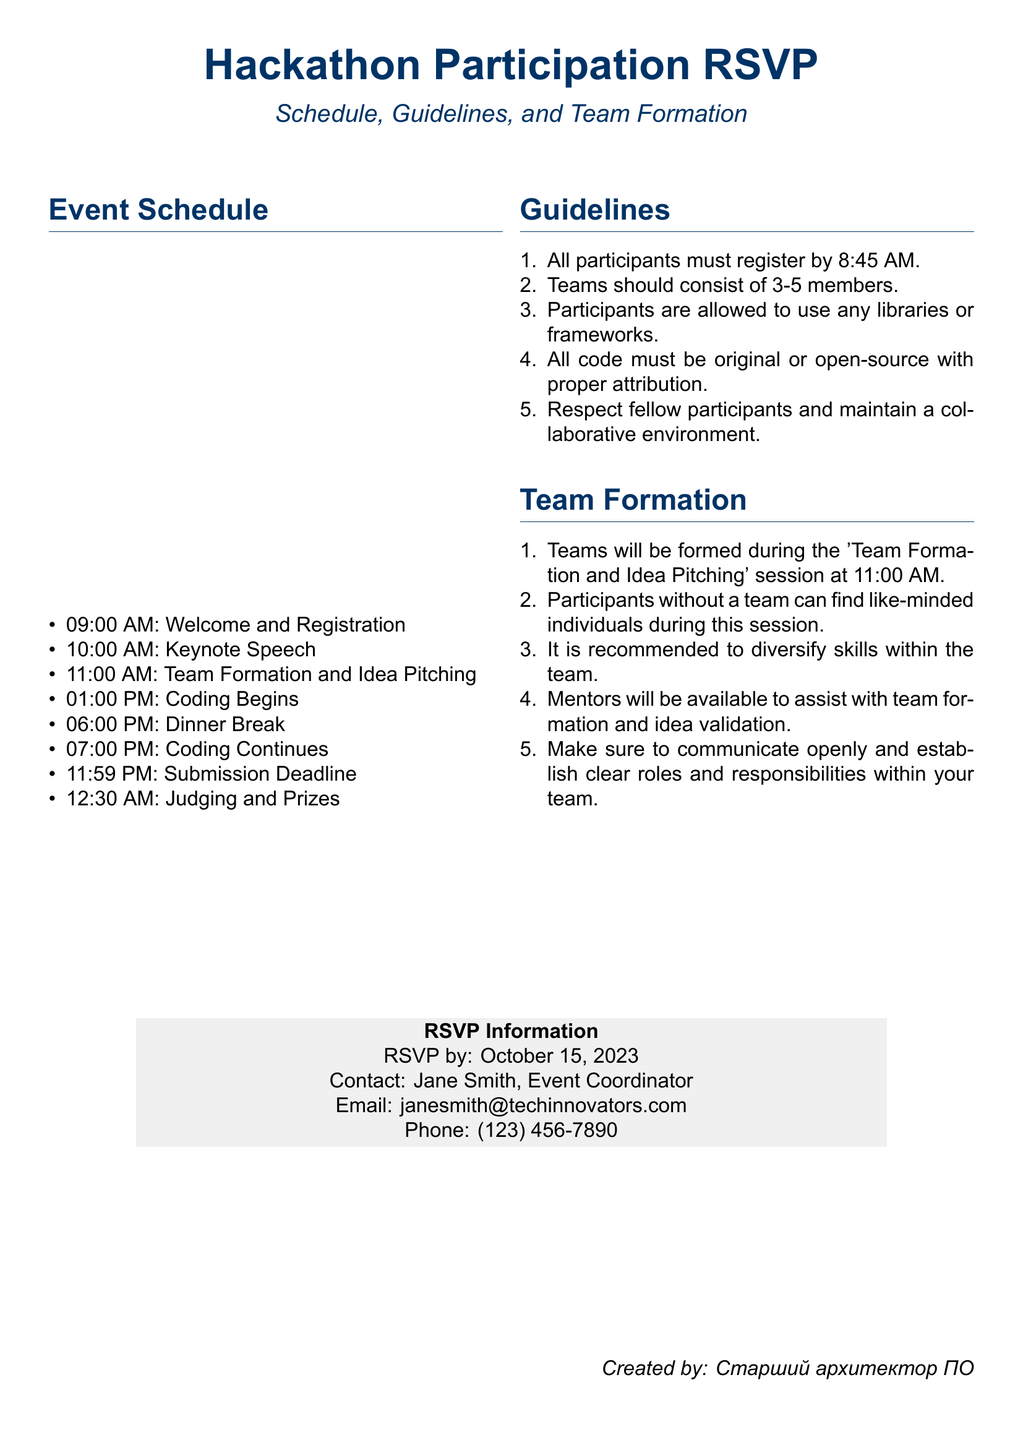what time does registration start? Registration begins at 09:00 AM as stated in the event schedule section.
Answer: 09:00 AM what is the last time to submit code? The submission deadline is mentioned as 11:59 PM in the event schedule.
Answer: 11:59 PM how many members should teams consist of? The guidelines specify that teams should consist of 3-5 members.
Answer: 3-5 members when is the RSVP deadline? The RSVP information states that participants must RSVP by October 15, 2023.
Answer: October 15, 2023 what role do mentors play during the event? Mentors are available to assist with team formation and idea validation according to the team formation guidelines.
Answer: Assist with team formation and idea validation what is the first activity of the day? The first activity of the day is welcome and registration as per the event schedule.
Answer: Welcome and Registration how long is the dinner break? The event schedule does not specify the duration of the dinner break, but it starts at 06:00 PM.
Answer: Not specified what is expected from participants regarding collaboration? Participants are expected to respect fellow participants and maintain a collaborative environment as outlined in the guidelines.
Answer: Respect fellow participants and maintain a collaborative environment where should participants send their RSVP? Participants can send their RSVPs to Jane Smith, and her contact information is provided in the RSVP information.
Answer: Jane Smith, email provided 